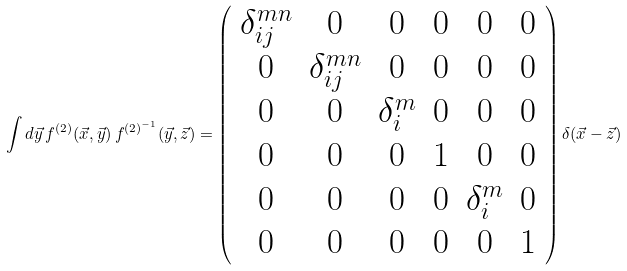<formula> <loc_0><loc_0><loc_500><loc_500>\int d \vec { y } \, f ^ { ( 2 ) } ( \vec { x } , \vec { y } ) \, f ^ { ( 2 ) ^ { - 1 } } ( \vec { y } , \vec { z } ) = \left ( \begin{array} { c c c c c c } \delta _ { i j } ^ { m n } & 0 & 0 & 0 & 0 & 0 \\ 0 & \delta _ { i j } ^ { m n } & 0 & 0 & 0 & 0 \\ 0 & 0 & \delta _ { i } ^ { m } & 0 & 0 & 0 \\ 0 & 0 & 0 & 1 & 0 & 0 \\ 0 & 0 & 0 & 0 & \delta _ { i } ^ { m } & 0 \\ 0 & 0 & 0 & 0 & 0 & 1 \\ \end{array} \right ) \delta ( \vec { x } - \vec { z } )</formula> 